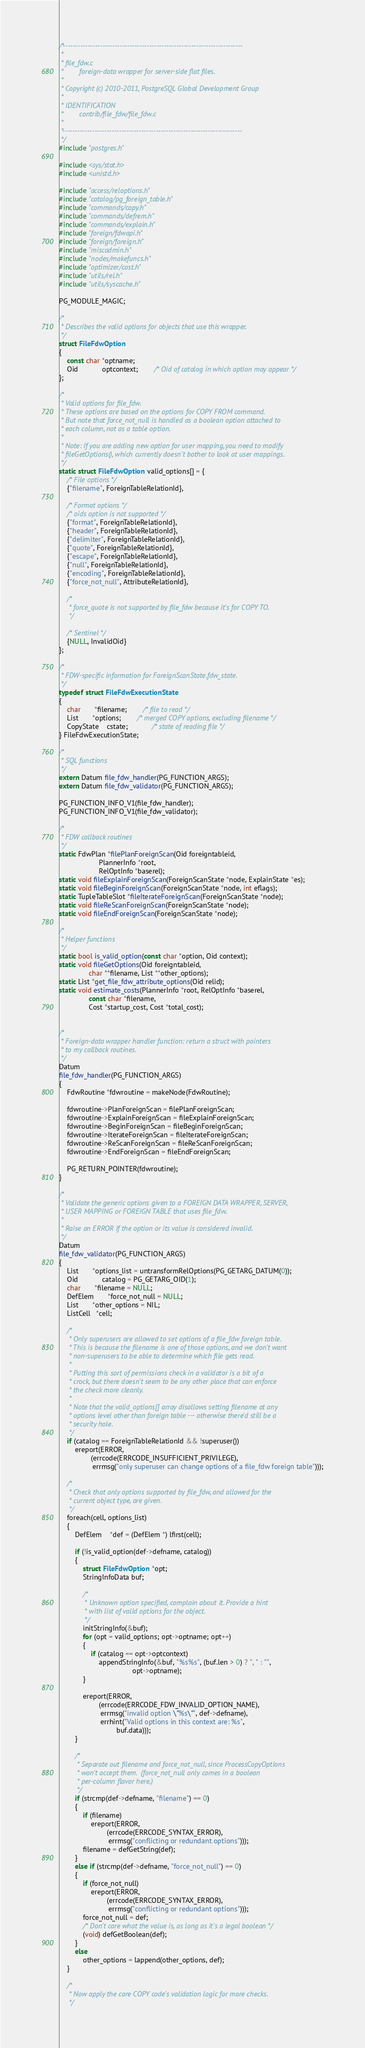Convert code to text. <code><loc_0><loc_0><loc_500><loc_500><_C_>/*-------------------------------------------------------------------------
 *
 * file_fdw.c
 *		  foreign-data wrapper for server-side flat files.
 *
 * Copyright (c) 2010-2011, PostgreSQL Global Development Group
 *
 * IDENTIFICATION
 *		  contrib/file_fdw/file_fdw.c
 *
 *-------------------------------------------------------------------------
 */
#include "postgres.h"

#include <sys/stat.h>
#include <unistd.h>

#include "access/reloptions.h"
#include "catalog/pg_foreign_table.h"
#include "commands/copy.h"
#include "commands/defrem.h"
#include "commands/explain.h"
#include "foreign/fdwapi.h"
#include "foreign/foreign.h"
#include "miscadmin.h"
#include "nodes/makefuncs.h"
#include "optimizer/cost.h"
#include "utils/rel.h"
#include "utils/syscache.h"

PG_MODULE_MAGIC;

/*
 * Describes the valid options for objects that use this wrapper.
 */
struct FileFdwOption
{
	const char *optname;
	Oid			optcontext;		/* Oid of catalog in which option may appear */
};

/*
 * Valid options for file_fdw.
 * These options are based on the options for COPY FROM command.
 * But note that force_not_null is handled as a boolean option attached to
 * each column, not as a table option.
 *
 * Note: If you are adding new option for user mapping, you need to modify
 * fileGetOptions(), which currently doesn't bother to look at user mappings.
 */
static struct FileFdwOption valid_options[] = {
	/* File options */
	{"filename", ForeignTableRelationId},

	/* Format options */
	/* oids option is not supported */
	{"format", ForeignTableRelationId},
	{"header", ForeignTableRelationId},
	{"delimiter", ForeignTableRelationId},
	{"quote", ForeignTableRelationId},
	{"escape", ForeignTableRelationId},
	{"null", ForeignTableRelationId},
	{"encoding", ForeignTableRelationId},
	{"force_not_null", AttributeRelationId},

	/*
	 * force_quote is not supported by file_fdw because it's for COPY TO.
	 */

	/* Sentinel */
	{NULL, InvalidOid}
};

/*
 * FDW-specific information for ForeignScanState.fdw_state.
 */
typedef struct FileFdwExecutionState
{
	char	   *filename;		/* file to read */
	List	   *options;		/* merged COPY options, excluding filename */
	CopyState	cstate;			/* state of reading file */
} FileFdwExecutionState;

/*
 * SQL functions
 */
extern Datum file_fdw_handler(PG_FUNCTION_ARGS);
extern Datum file_fdw_validator(PG_FUNCTION_ARGS);

PG_FUNCTION_INFO_V1(file_fdw_handler);
PG_FUNCTION_INFO_V1(file_fdw_validator);

/*
 * FDW callback routines
 */
static FdwPlan *filePlanForeignScan(Oid foreigntableid,
					PlannerInfo *root,
					RelOptInfo *baserel);
static void fileExplainForeignScan(ForeignScanState *node, ExplainState *es);
static void fileBeginForeignScan(ForeignScanState *node, int eflags);
static TupleTableSlot *fileIterateForeignScan(ForeignScanState *node);
static void fileReScanForeignScan(ForeignScanState *node);
static void fileEndForeignScan(ForeignScanState *node);

/*
 * Helper functions
 */
static bool is_valid_option(const char *option, Oid context);
static void fileGetOptions(Oid foreigntableid,
			   char **filename, List **other_options);
static List *get_file_fdw_attribute_options(Oid relid);
static void estimate_costs(PlannerInfo *root, RelOptInfo *baserel,
			   const char *filename,
			   Cost *startup_cost, Cost *total_cost);


/*
 * Foreign-data wrapper handler function: return a struct with pointers
 * to my callback routines.
 */
Datum
file_fdw_handler(PG_FUNCTION_ARGS)
{
	FdwRoutine *fdwroutine = makeNode(FdwRoutine);

	fdwroutine->PlanForeignScan = filePlanForeignScan;
	fdwroutine->ExplainForeignScan = fileExplainForeignScan;
	fdwroutine->BeginForeignScan = fileBeginForeignScan;
	fdwroutine->IterateForeignScan = fileIterateForeignScan;
	fdwroutine->ReScanForeignScan = fileReScanForeignScan;
	fdwroutine->EndForeignScan = fileEndForeignScan;

	PG_RETURN_POINTER(fdwroutine);
}

/*
 * Validate the generic options given to a FOREIGN DATA WRAPPER, SERVER,
 * USER MAPPING or FOREIGN TABLE that uses file_fdw.
 *
 * Raise an ERROR if the option or its value is considered invalid.
 */
Datum
file_fdw_validator(PG_FUNCTION_ARGS)
{
	List	   *options_list = untransformRelOptions(PG_GETARG_DATUM(0));
	Oid			catalog = PG_GETARG_OID(1);
	char	   *filename = NULL;
	DefElem	   *force_not_null = NULL;
	List	   *other_options = NIL;
	ListCell   *cell;

	/*
	 * Only superusers are allowed to set options of a file_fdw foreign table.
	 * This is because the filename is one of those options, and we don't want
	 * non-superusers to be able to determine which file gets read.
	 *
	 * Putting this sort of permissions check in a validator is a bit of a
	 * crock, but there doesn't seem to be any other place that can enforce
	 * the check more cleanly.
	 *
	 * Note that the valid_options[] array disallows setting filename at any
	 * options level other than foreign table --- otherwise there'd still be a
	 * security hole.
	 */
	if (catalog == ForeignTableRelationId && !superuser())
		ereport(ERROR,
				(errcode(ERRCODE_INSUFFICIENT_PRIVILEGE),
				 errmsg("only superuser can change options of a file_fdw foreign table")));

	/*
	 * Check that only options supported by file_fdw, and allowed for the
	 * current object type, are given.
	 */
	foreach(cell, options_list)
	{
		DefElem    *def = (DefElem *) lfirst(cell);

		if (!is_valid_option(def->defname, catalog))
		{
			struct FileFdwOption *opt;
			StringInfoData buf;

			/*
			 * Unknown option specified, complain about it. Provide a hint
			 * with list of valid options for the object.
			 */
			initStringInfo(&buf);
			for (opt = valid_options; opt->optname; opt++)
			{
				if (catalog == opt->optcontext)
					appendStringInfo(&buf, "%s%s", (buf.len > 0) ? ", " : "",
									 opt->optname);
			}

			ereport(ERROR,
					(errcode(ERRCODE_FDW_INVALID_OPTION_NAME),
					 errmsg("invalid option \"%s\"", def->defname),
					 errhint("Valid options in this context are: %s",
							 buf.data)));
		}

		/*
		 * Separate out filename and force_not_null, since ProcessCopyOptions
		 * won't accept them.  (force_not_null only comes in a boolean
		 * per-column flavor here.)
		 */
		if (strcmp(def->defname, "filename") == 0)
		{
			if (filename)
				ereport(ERROR,
						(errcode(ERRCODE_SYNTAX_ERROR),
						 errmsg("conflicting or redundant options")));
			filename = defGetString(def);
		}
		else if (strcmp(def->defname, "force_not_null") == 0)
		{
			if (force_not_null)
				ereport(ERROR,
						(errcode(ERRCODE_SYNTAX_ERROR),
						 errmsg("conflicting or redundant options")));
			force_not_null = def;
			/* Don't care what the value is, as long as it's a legal boolean */
			(void) defGetBoolean(def);
		}
		else
			other_options = lappend(other_options, def);
	}

	/*
	 * Now apply the core COPY code's validation logic for more checks.
	 */</code> 